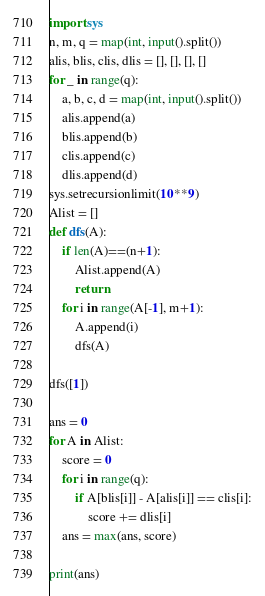Convert code to text. <code><loc_0><loc_0><loc_500><loc_500><_Python_>import sys
n, m, q = map(int, input().split())
alis, blis, clis, dlis = [], [], [], []
for _ in range(q):
    a, b, c, d = map(int, input().split())
    alis.append(a)
    blis.append(b)
    clis.append(c)
    dlis.append(d)
sys.setrecursionlimit(10**9)
Alist = [] 
def dfs(A):
    if len(A)==(n+1):
        Alist.append(A)
        return
    for i in range(A[-1], m+1):
        A.append(i)
        dfs(A)

dfs([1])

ans = 0
for A in Alist:
    score = 0
    for i in range(q):
        if A[blis[i]] - A[alis[i]] == clis[i]:
            score += dlis[i]
    ans = max(ans, score)

print(ans)</code> 